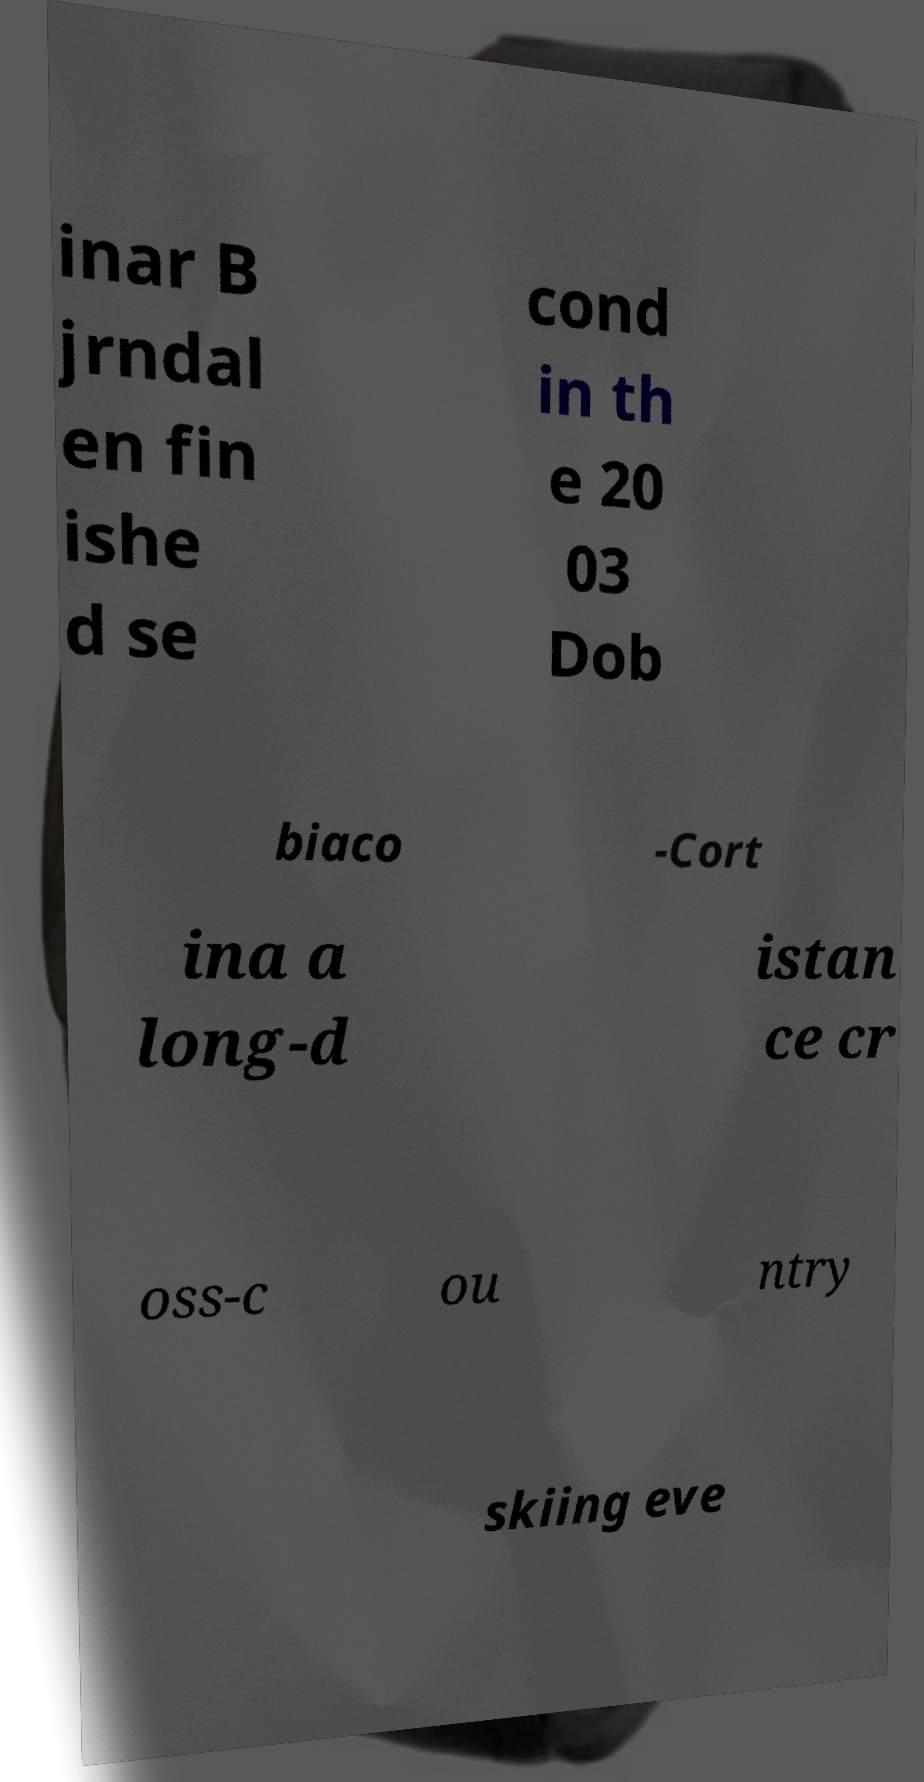Could you extract and type out the text from this image? inar B jrndal en fin ishe d se cond in th e 20 03 Dob biaco -Cort ina a long-d istan ce cr oss-c ou ntry skiing eve 